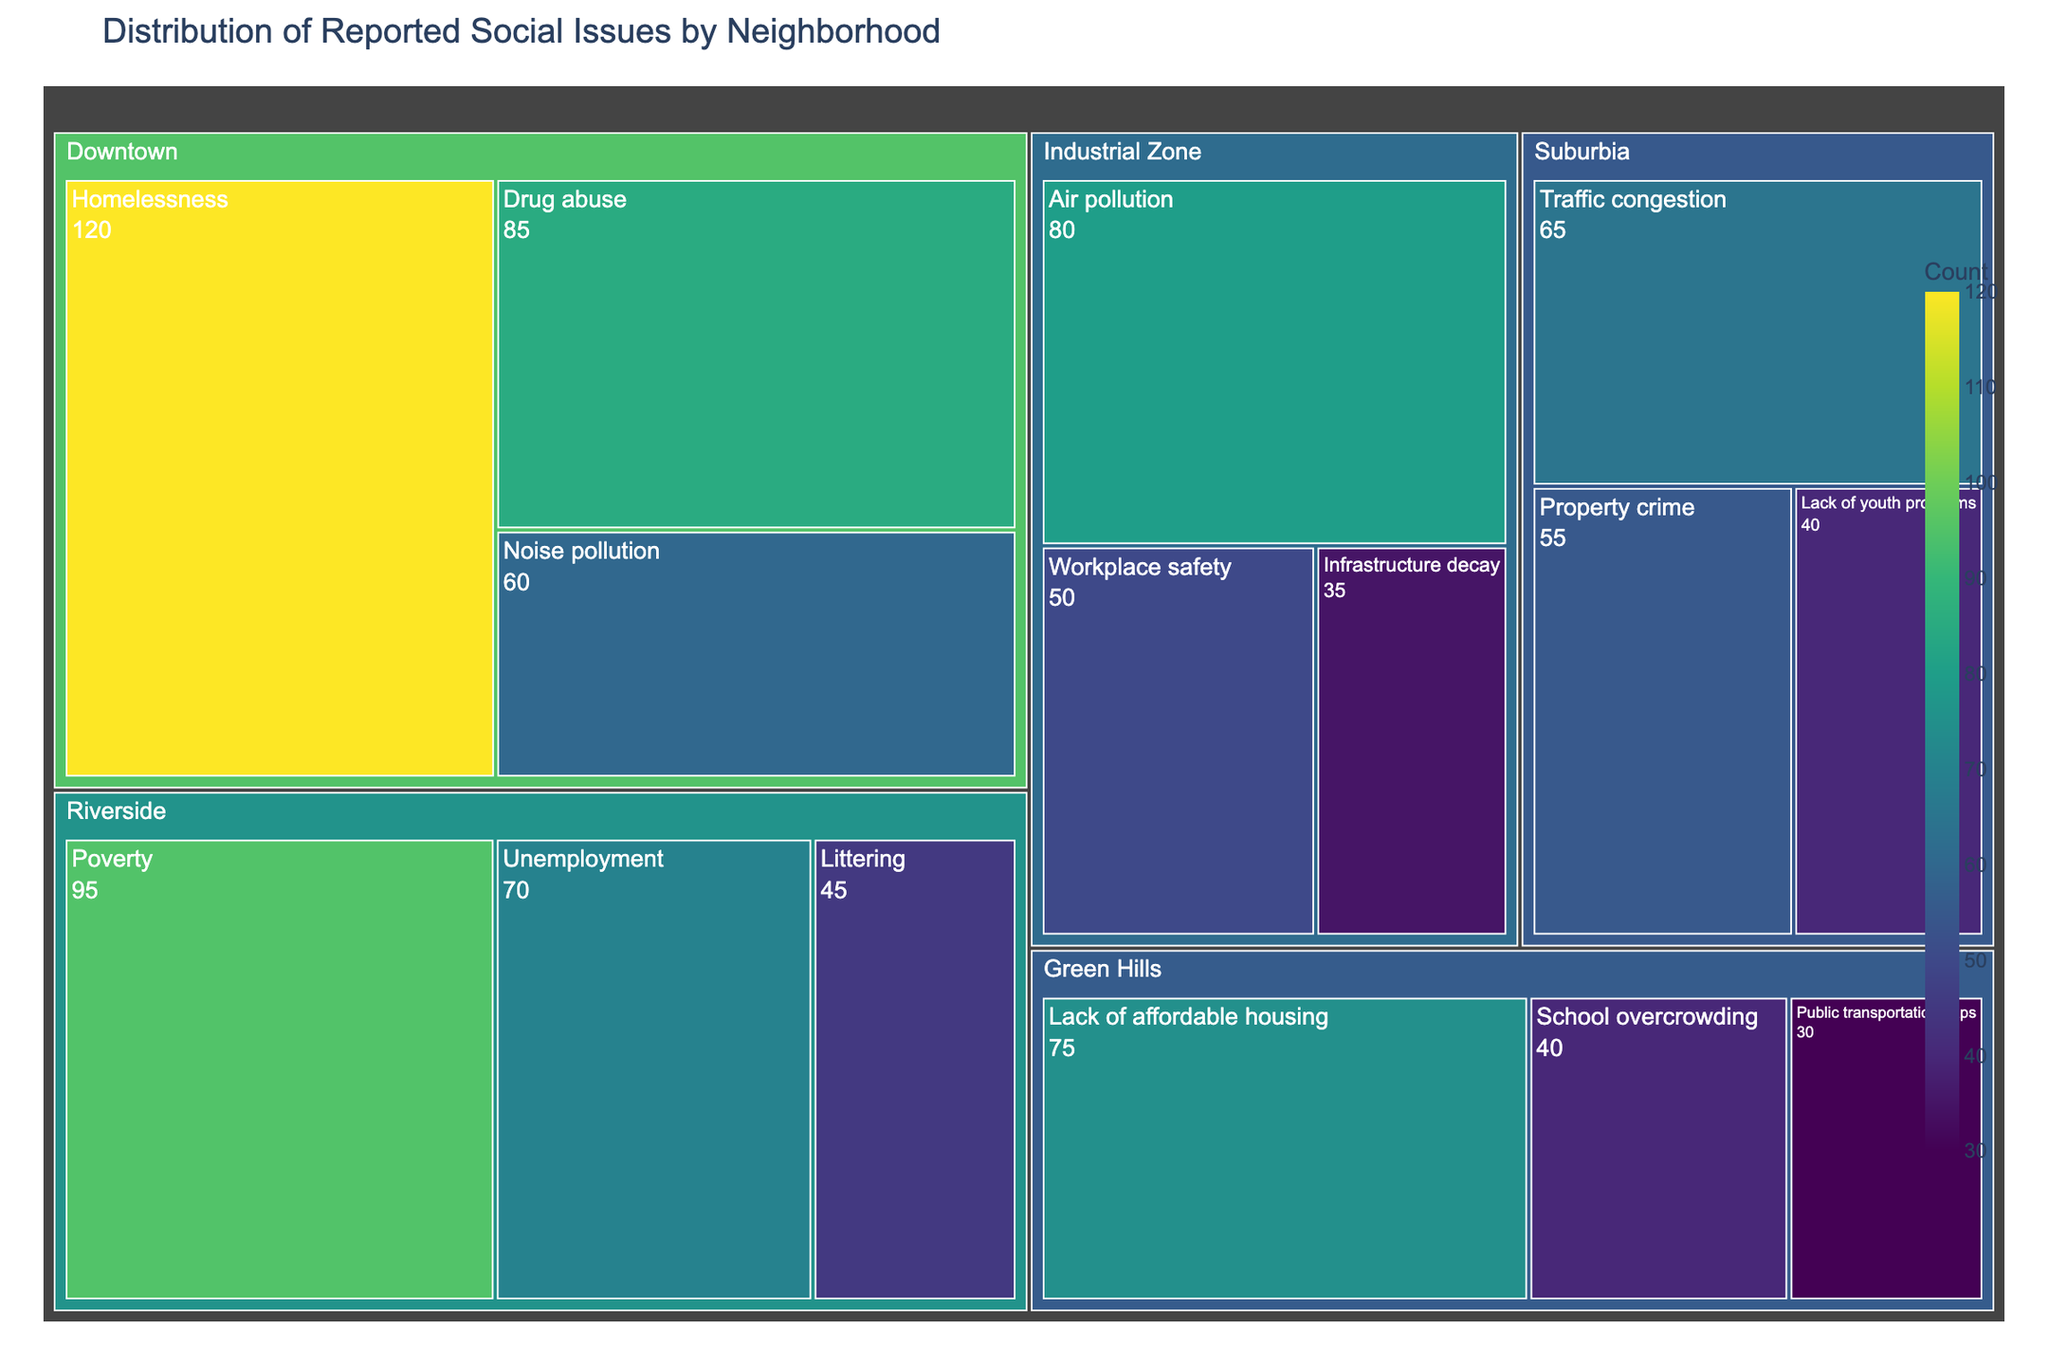What's the title of the treemap? The title is usually displayed at the top of the figure. It provides a high-level description of what the figure represents.
Answer: Distribution of Reported Social Issues by Neighborhood Which neighborhood has the highest count of reported issues? To determine this, look for the largest section in the treemap. Downtown has the largest combined area, indicating the highest count.
Answer: Downtown What social issue has the highest count in Downtown? To find this, look for the largest rectangle within Downtown. Homelessness is the largest section within Downtown.
Answer: Homelessness How does the count of Drug abuse in Downtown compare to Air pollution in the Industrial Zone? Compare the size of the Drug abuse rectangle in Downtown to the Air pollution rectangle in the Industrial Zone. Drug abuse has a count of 85 while Air pollution has a count of 80.
Answer: Drug abuse is higher What is the combined count of social issues in Riverside? Sum the counts of all issues in Riverside: Poverty (95), Unemployment (70), Littering (45). 95 + 70 + 45 = 210.
Answer: 210 Which neighborhood has the issue with the smallest count and what is the count? Find the smallest rectangle overall in the treemap. The smallest section is Public transportation gaps in Green Hills with a count of 30.
Answer: Green Hills, 30 What is the total count of reported social issues in Green Hills? Sum the counts of all issues in Green Hills: Lack of affordable housing (75), School overcrowding (40), Public transportation gaps (30). 75 + 40 + 30 = 145.
Answer: 145 Which neighborhood has the largest diversity of social issues reported? Count the number of different issues within each neighborhood. Downtown, Riverside, and Industrial Zone each report 3 distinct issues. The size of reported issues is most diverse in terms of counts but all three have the same range of distinct issues.
Answer: Downtown, Riverside, Industrial Zone How does Property crime in Suburbia compare to Noise pollution in Downtown? Compare the sizes of the respective rectangles in the treemap. Property crime in Suburbia has a count of 55, whereas Noise pollution in Downtown has a count of 60.
Answer: Noise pollution is higher 